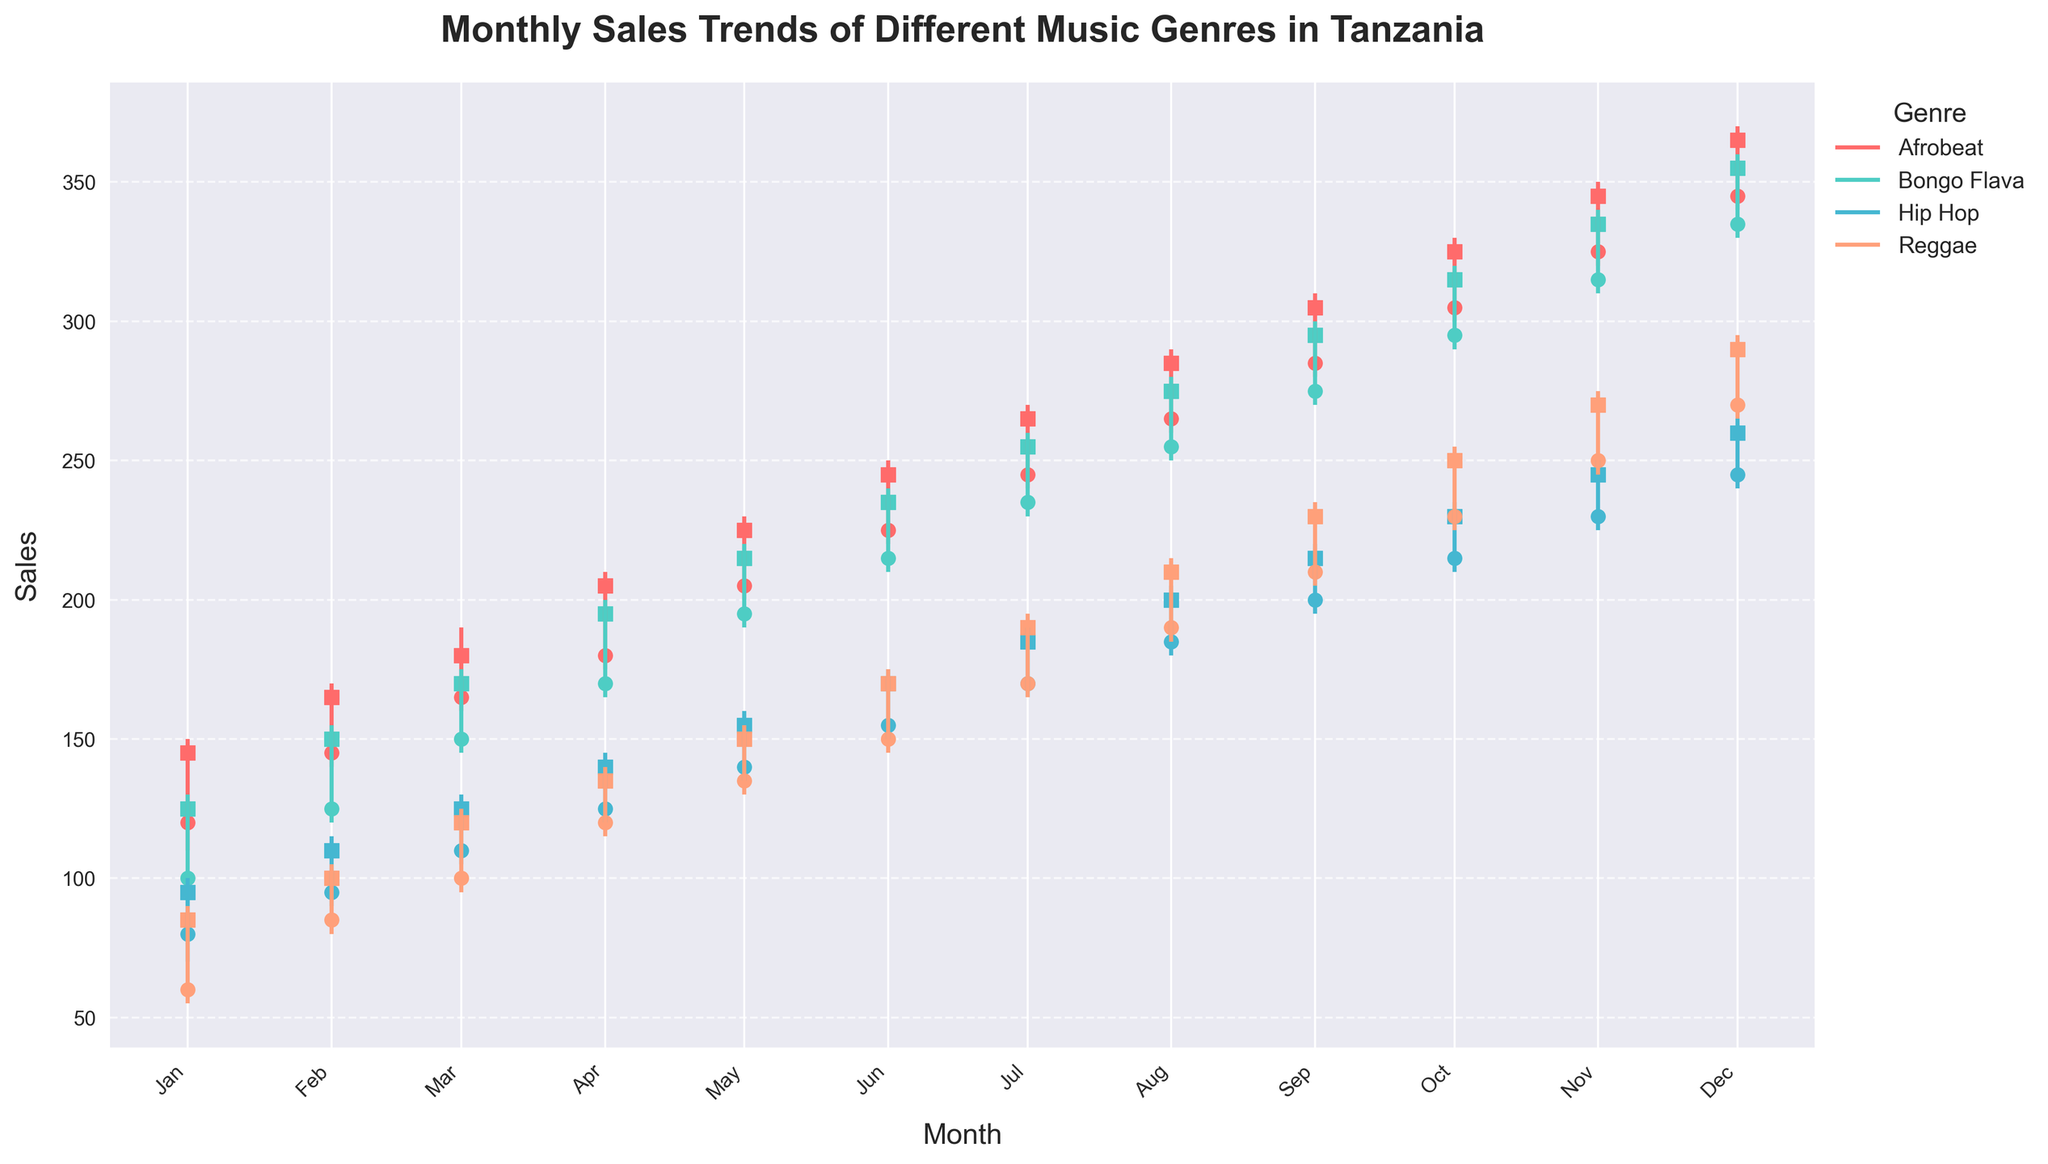What is the title of the plot? The title of the plot is prominently displayed at the top of the figure to provide context about the information being presented. In this case, the title tells us the subject of the plot, which is about music sales trends in Tanzania.
Answer: Monthly Sales Trends of Different Music Genres in Tanzania Which genre had the highest close value in October 2023? By examining the candlestick plot for each genre in October 2023, one can identify the highest close value. The close values are represented by the square markers.
Answer: Afrobeat What is the overall trend for Hip Hop sales from January to December 2023? Observing the candlestick figures for Hip Hop from January to December 2023, one can see that both the low and high values, as well as the open and close values, generally increase over time.
Answer: Increasing Which month shows the highest sales for Bongo Flava? By looking at the high values on the candlestick figures, one can determine that December 2023 has the highest peak for Bongo Flava sales.
Answer: December 2023 What's the range of sales (difference between high and low) for Reggae in June 2023? To find the range, subtract the low value from the high value for Reggae in June 2023. The high is 175 and the low is 145.
Answer: 30 In which month do all genres show an increase in close values compared to the previous month? By observing the difference between the close values of two consecutive months for each genre, we notice that all genres show an increase in April 2023 compared to March 2023.
Answer: April 2023 How does the sales trend of Afrobeat compare to Bongo Flava throughout the year? By comparing their candlestick figures over the months, we can observe that Afrobeat consistently has higher values in open, high, low, and close values compared to Bongo Flava.
Answer: Afrobeat has higher sales Which genre had the largest volatility (difference between high and low) in December 2023? By examining the difference between high and low values for all genres in December 2023, we see that Afrobeat shows the largest difference. High is 370 and low is 340, making the range 30.
Answer: Afrobeat What is the sum of the open values for Reggae from January to December? Adding the open values for Reggae from each month (60+85+100+120+135+150+170+190+210+230+250+270) gives us the total open values.
Answer: 2070 